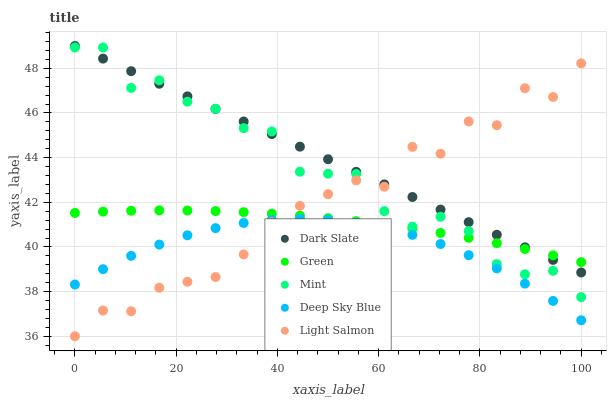Does Deep Sky Blue have the minimum area under the curve?
Answer yes or no. Yes. Does Dark Slate have the maximum area under the curve?
Answer yes or no. Yes. Does Light Salmon have the minimum area under the curve?
Answer yes or no. No. Does Light Salmon have the maximum area under the curve?
Answer yes or no. No. Is Dark Slate the smoothest?
Answer yes or no. Yes. Is Light Salmon the roughest?
Answer yes or no. Yes. Is Green the smoothest?
Answer yes or no. No. Is Green the roughest?
Answer yes or no. No. Does Light Salmon have the lowest value?
Answer yes or no. Yes. Does Green have the lowest value?
Answer yes or no. No. Does Dark Slate have the highest value?
Answer yes or no. Yes. Does Light Salmon have the highest value?
Answer yes or no. No. Is Deep Sky Blue less than Green?
Answer yes or no. Yes. Is Green greater than Deep Sky Blue?
Answer yes or no. Yes. Does Light Salmon intersect Deep Sky Blue?
Answer yes or no. Yes. Is Light Salmon less than Deep Sky Blue?
Answer yes or no. No. Is Light Salmon greater than Deep Sky Blue?
Answer yes or no. No. Does Deep Sky Blue intersect Green?
Answer yes or no. No. 